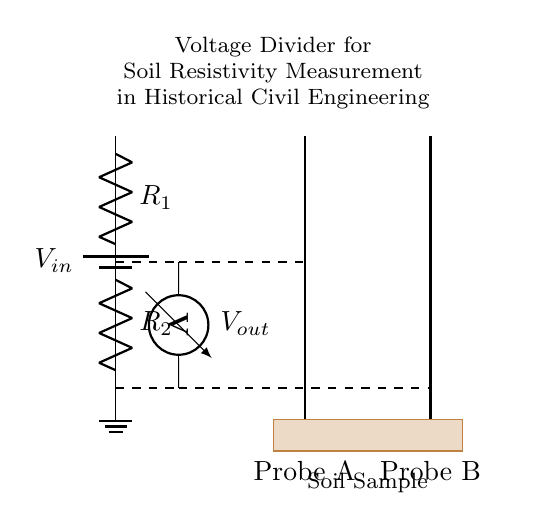What is the purpose of the resistors in this circuit? The resistors, labeled as R1 and R2, are part of the voltage divider configuration. They divide the input voltage into a smaller output voltage that can be measured across one of the resistors.
Answer: Voltage division What does the voltmeter measure in this circuit? The voltmeter measures the voltage output (Vout) across either resistor, typically R2. This measurement is crucial for calculating the soil resistivity based on the applied voltage and the measured voltage.
Answer: Voltage output How many probes are used in this soil resistivity measurement? There are two probes, Probe A and Probe B, which are used to measure the resistance of the soil between them, contributing to the overall soil resistivity calculation.
Answer: Two probes What does the term 'soil sample' refer to in this circuit? The 'soil sample' refers to the portion of ground or material present between the two probes, where the electrical resistance will be measured to determine its resistivity properties.
Answer: Soil material What is the relationship between the resistors and the output voltage in this circuit? The output voltage (Vout) is determined by the values of the resistors (R1 and R2) in accordance with the voltage divider formula: Vout = Vin * (R2 / (R1 + R2)). This shows how the larger R2 relative to R1 will yield a higher Vout.
Answer: Voltage divider formula What is the significance of using a voltage divider in soil resistivity measurement? A voltage divider allows for the precise measurement of the voltage drop across the soil, which can then be related to soil resistivity by accounting for the known input voltage and resistances involved.
Answer: Soil resistivity measurement 